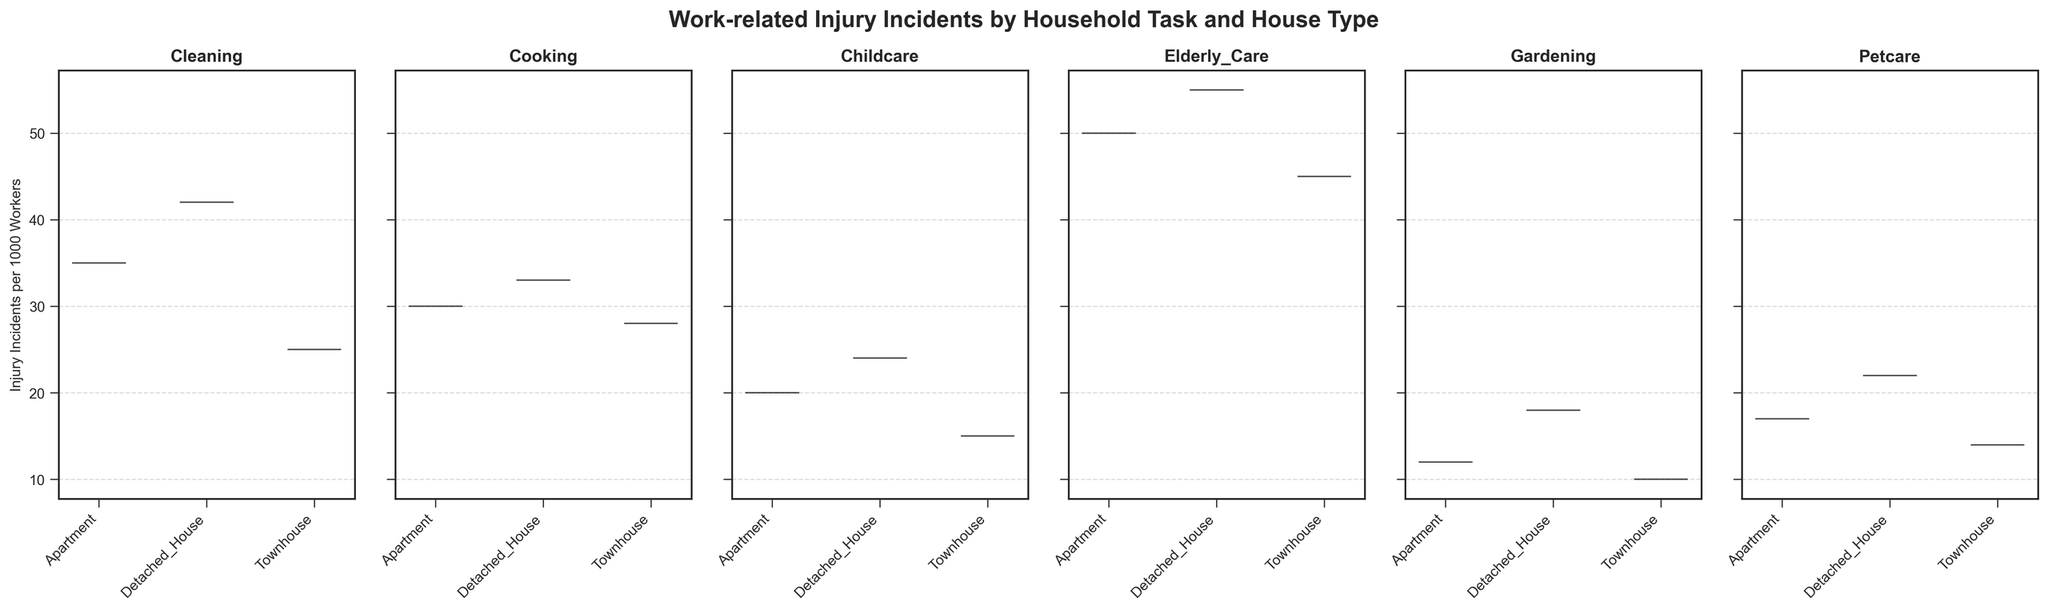What is the general trend in injury incidents among different household tasks? By looking at the figure, we see that injury incidents vary by household task. Cleaning, Cooking, and Elderly Care have higher incidents, while tasks like Petcare and Gardening have lower incidents.
Answer: Cleaning, Cooking, and Elderly Care have higher incidents Which household task in detached houses has the highest injury incidents per 1000 workers? From the detached house segment, Elderly Care has the highest incident rate. The violin for Elderly Care in detached houses is positioned highest on the y-axis.
Answer: Elderly Care Compare the injury incidents in apartments and townhouses for Childcare. Which type has fewer incidents? For Childcare, the violin plots show that townhouses have a lower range of injury incidents compared to apartments. The townhouses' plot is positioned lower than apartments.
Answer: Townhouses What is the range of injury incidents for Cooking tasks in detached houses? The figure shows a range of injury incidents for Cooking tasks in detached houses, visualizing the distribution data which approximately spans from around 30 to 33 incidents per 1000 workers.
Answer: 30 to 33 Among all household tasks, which task has the lowest range of injury incidents? The lowest range of injury incidents among all household tasks is observed in Gardening. This is evident as the violin plots for Gardening are positioned the lowest overall, across all house types.
Answer: Gardening Which household type generally shows more variation in injury incidents for Cleaning tasks? By comparing the widths of the violins for Cleaning tasks in different house types, detached houses show the broadest spread, indicating more variation in injury incidents.
Answer: Detached Houses Is there any task where townhouses generally show higher incidents compared to other house types? Elderly Care in townhouses shows lower injury incidents compared to apartments and detached houses. Other tasks like Cleaning and Cooking don't show townhouses having higher incidents either.
Answer: No For Petcare tasks, what are the approximate median injury incidents per house type? The violin shape along the y-axis can help infer approximate medians: Apartments (17), Detached Houses (22), Townhouses (14). These medians are near the central thickness of each plot.
Answer: Apartments: 17, Detached Houses: 22, Townhouses: 14 Which task has the smallest gap in injury incidents between apartments and detached houses? Looking at the viollin plots, Cooking has the smallest difference between apartments and detached houses. They are both situated closely in terms of y-coordinate values.
Answer: Cooking For which house type does Elderly Care show a noticeably lower injury incidents rate compared to other house types? From the violin plots, townhouses show a noticeably lower injury incidents rate for Elderly Care compared to both apartments and detached houses, indicated by a lower position on the y-axis.
Answer: Townhouses 